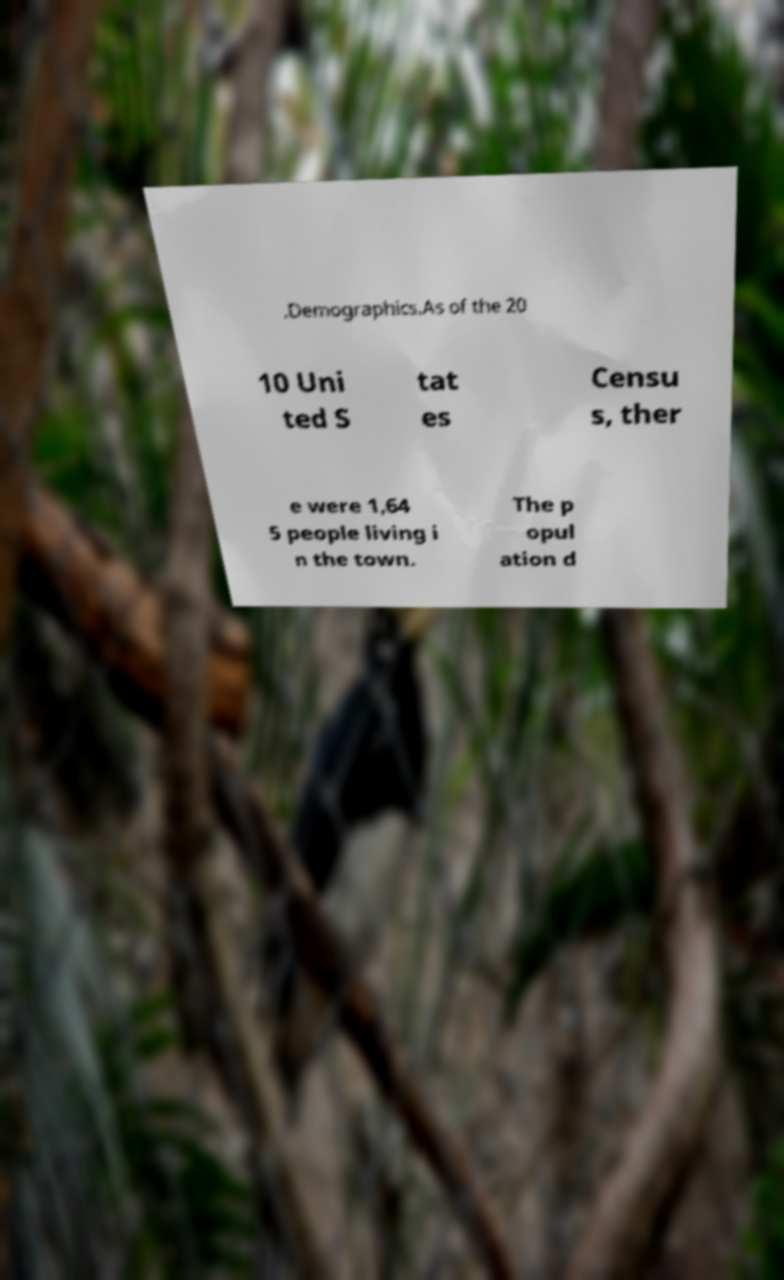What messages or text are displayed in this image? I need them in a readable, typed format. .Demographics.As of the 20 10 Uni ted S tat es Censu s, ther e were 1,64 5 people living i n the town. The p opul ation d 